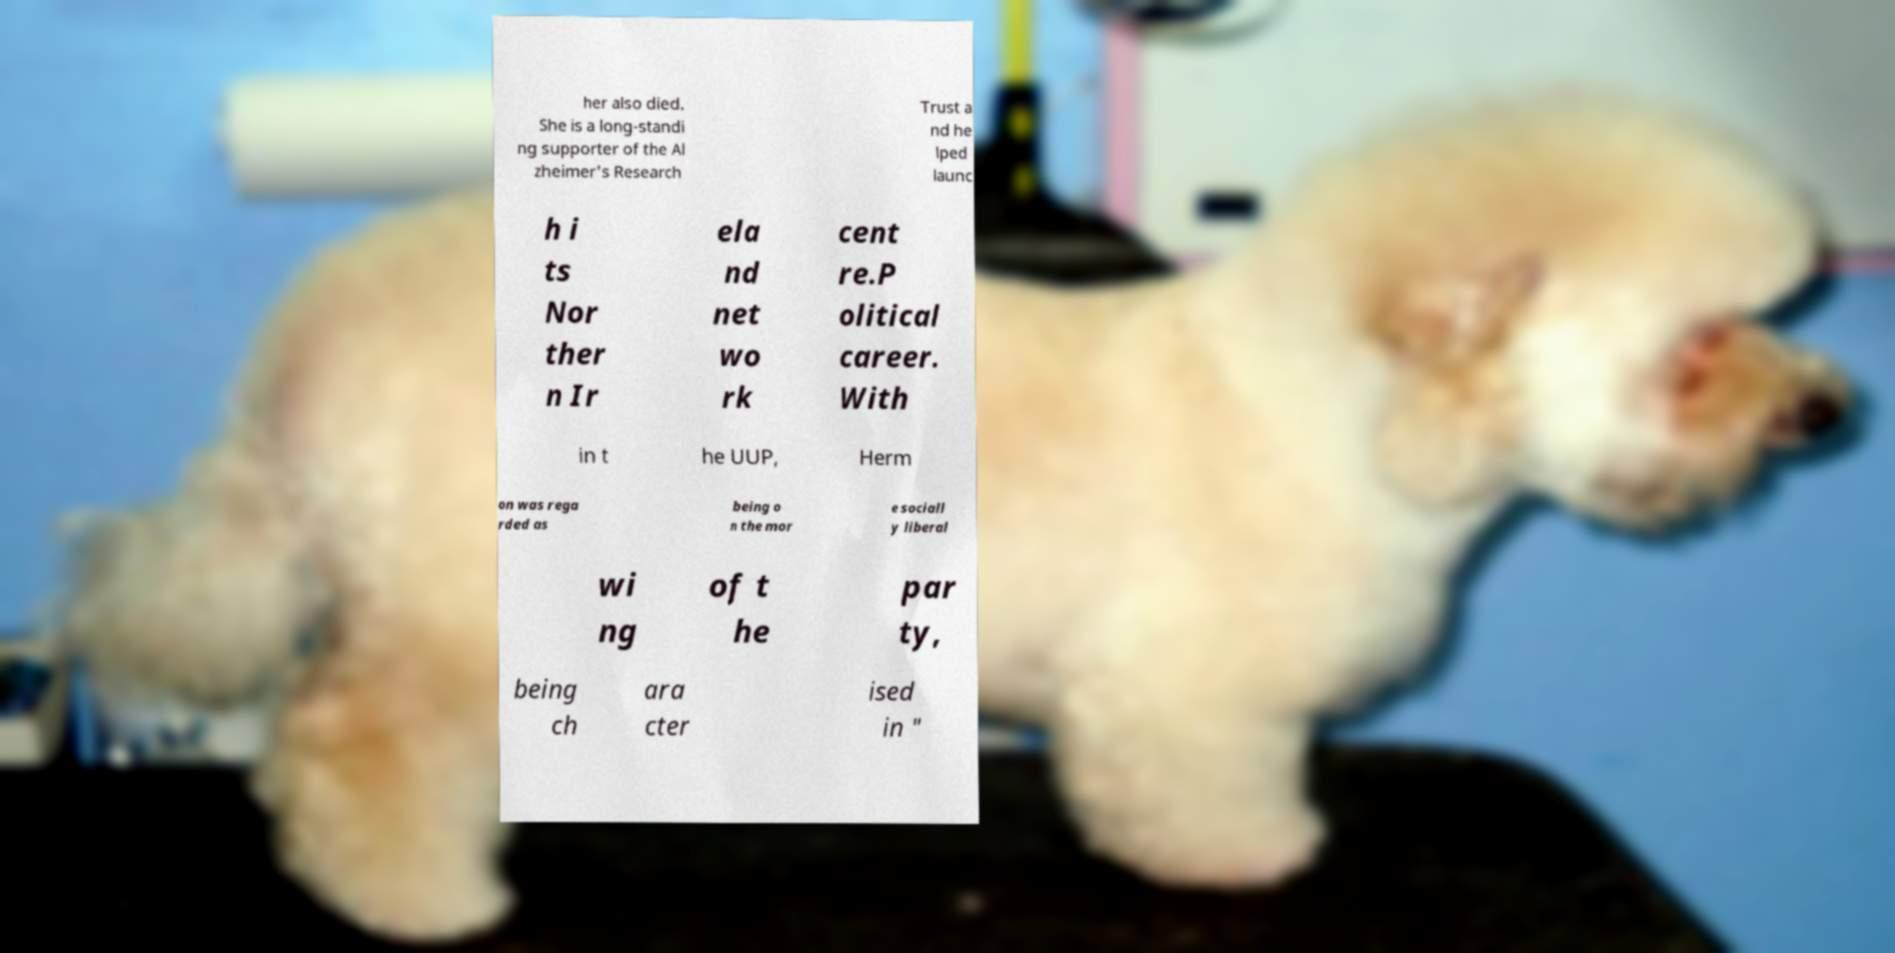For documentation purposes, I need the text within this image transcribed. Could you provide that? her also died. She is a long-standi ng supporter of the Al zheimer's Research Trust a nd he lped launc h i ts Nor ther n Ir ela nd net wo rk cent re.P olitical career. With in t he UUP, Herm on was rega rded as being o n the mor e sociall y liberal wi ng of t he par ty, being ch ara cter ised in " 